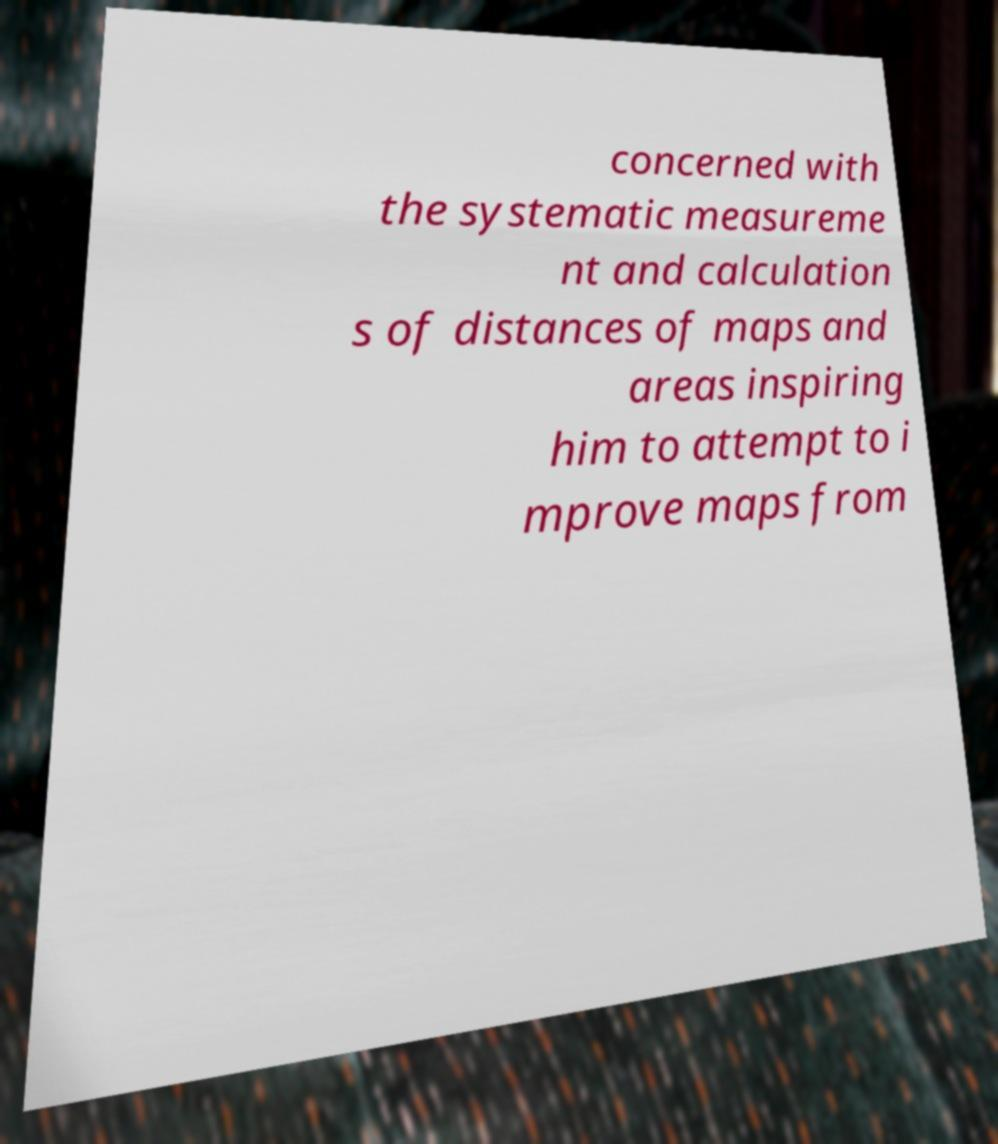Can you accurately transcribe the text from the provided image for me? concerned with the systematic measureme nt and calculation s of distances of maps and areas inspiring him to attempt to i mprove maps from 